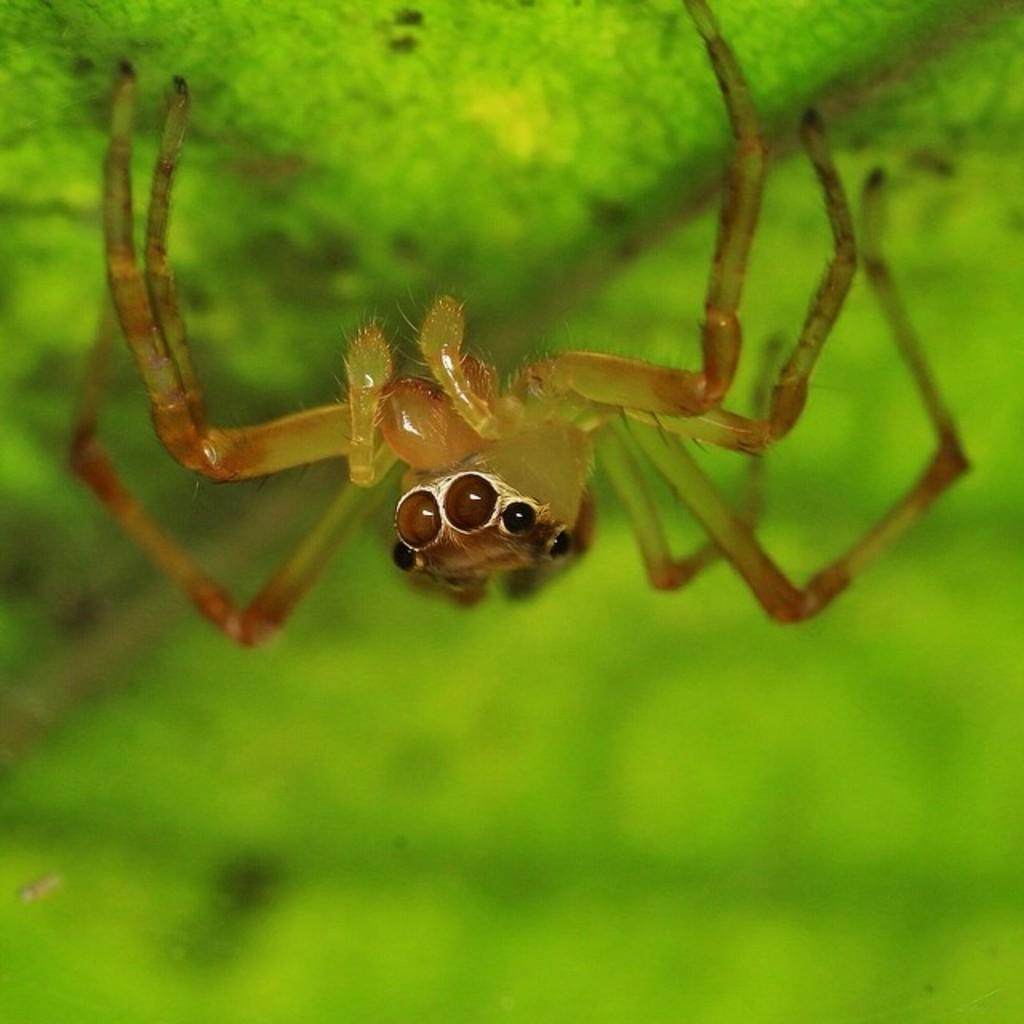What is the main subject of the image? The main subject of the image is a spider. What can you tell about the object the spider is on? The object the spider is on is green in color. How many locks are visible on the spider in the image? There are no locks present on the spider in the image, as spiders do not have locks. 